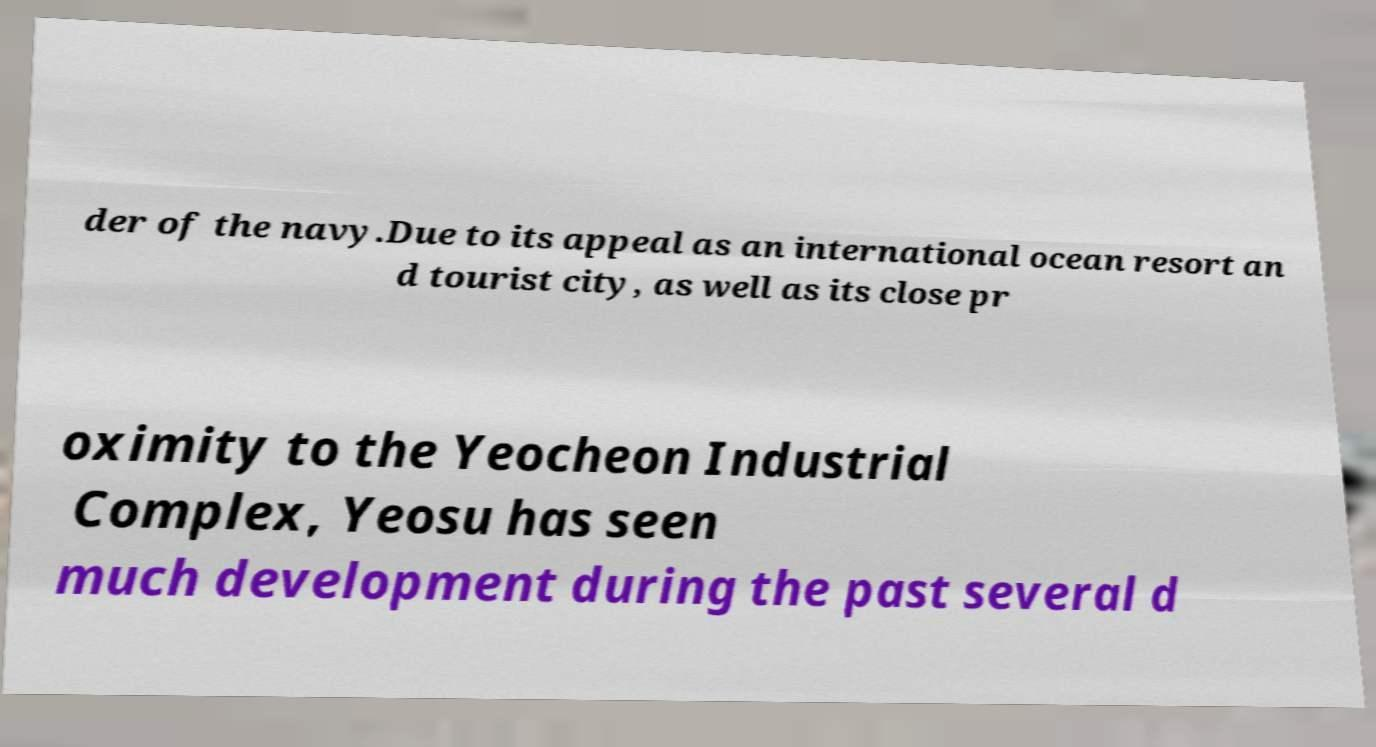Can you read and provide the text displayed in the image?This photo seems to have some interesting text. Can you extract and type it out for me? der of the navy.Due to its appeal as an international ocean resort an d tourist city, as well as its close pr oximity to the Yeocheon Industrial Complex, Yeosu has seen much development during the past several d 